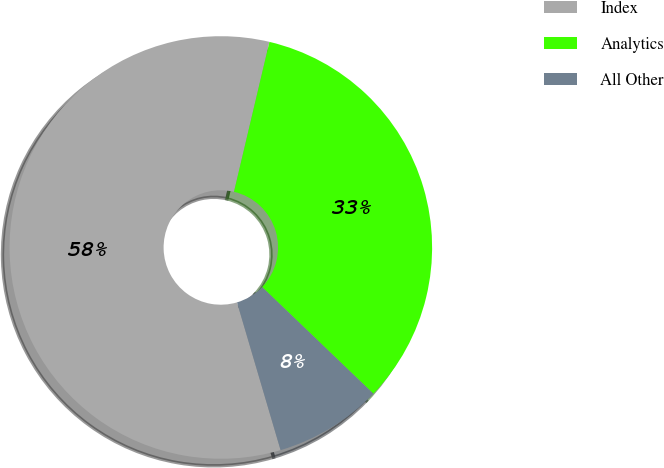<chart> <loc_0><loc_0><loc_500><loc_500><pie_chart><fcel>Index<fcel>Analytics<fcel>All Other<nl><fcel>58.26%<fcel>33.47%<fcel>8.27%<nl></chart> 